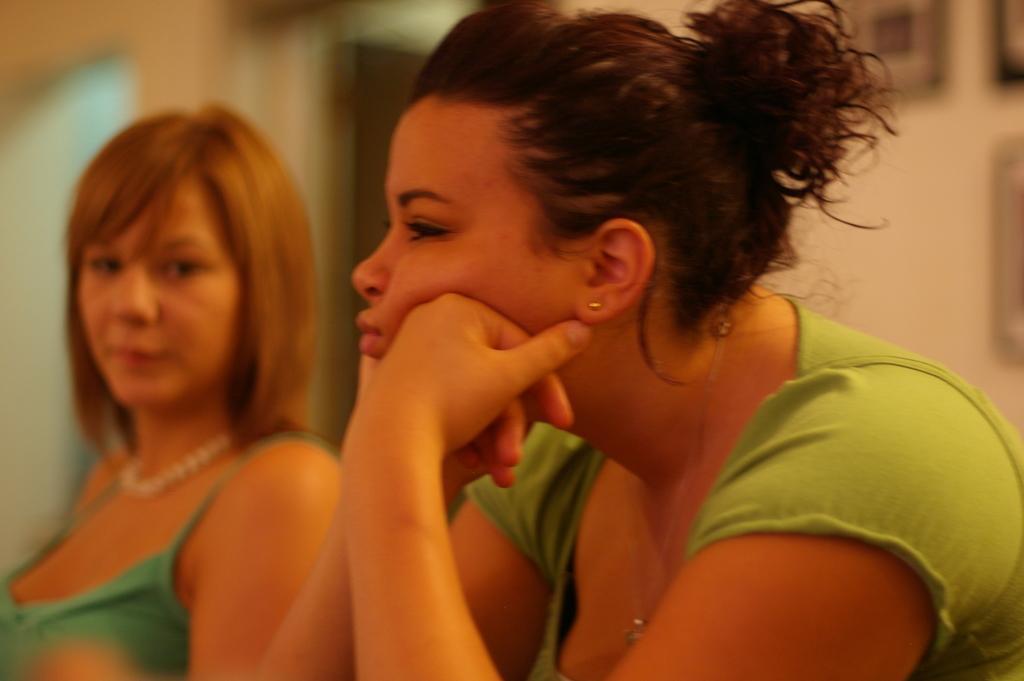How would you summarize this image in a sentence or two? In the foreground of the picture there is a woman. On the left there is another person. The background is blurred. 